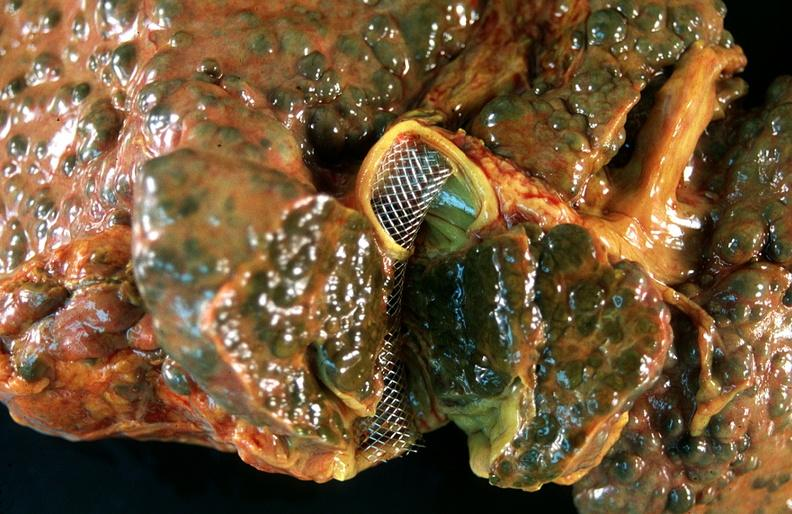s hemorrhage associated with placental abruption present?
Answer the question using a single word or phrase. No 